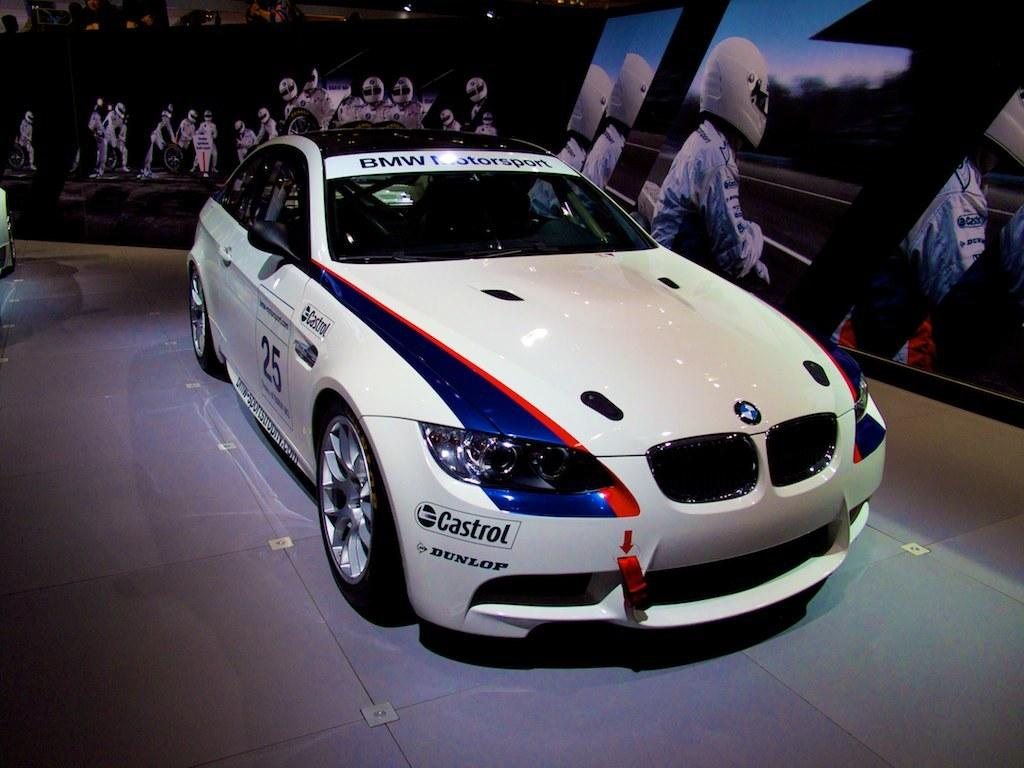What is the main subject in the center of the image? There is a car in the center of the image. What can be seen in the background of the image? There is a wall and a screen in the background of the image. What are the people on the screen wearing? The people on the screen are wearing helmets. How many feet are visible on the screen in the image? There are no feet visible on the screen in the image; the people on the screen are wearing helmets. 